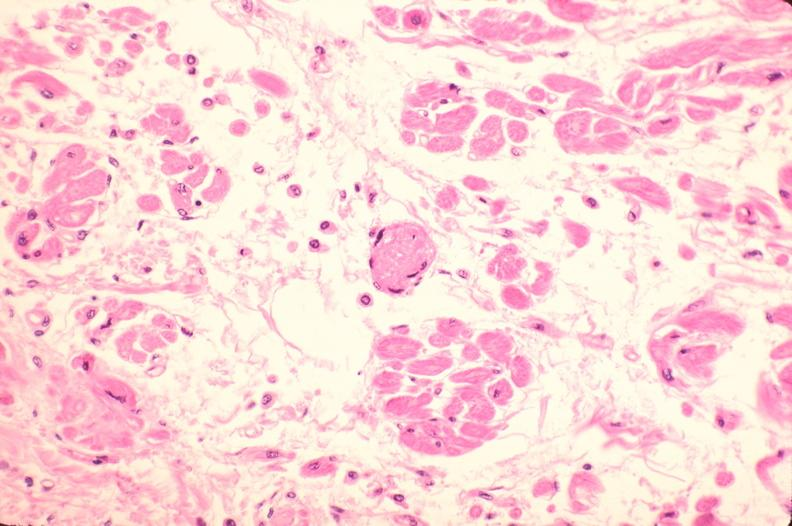where is this in?
Answer the question using a single word or phrase. In heart 